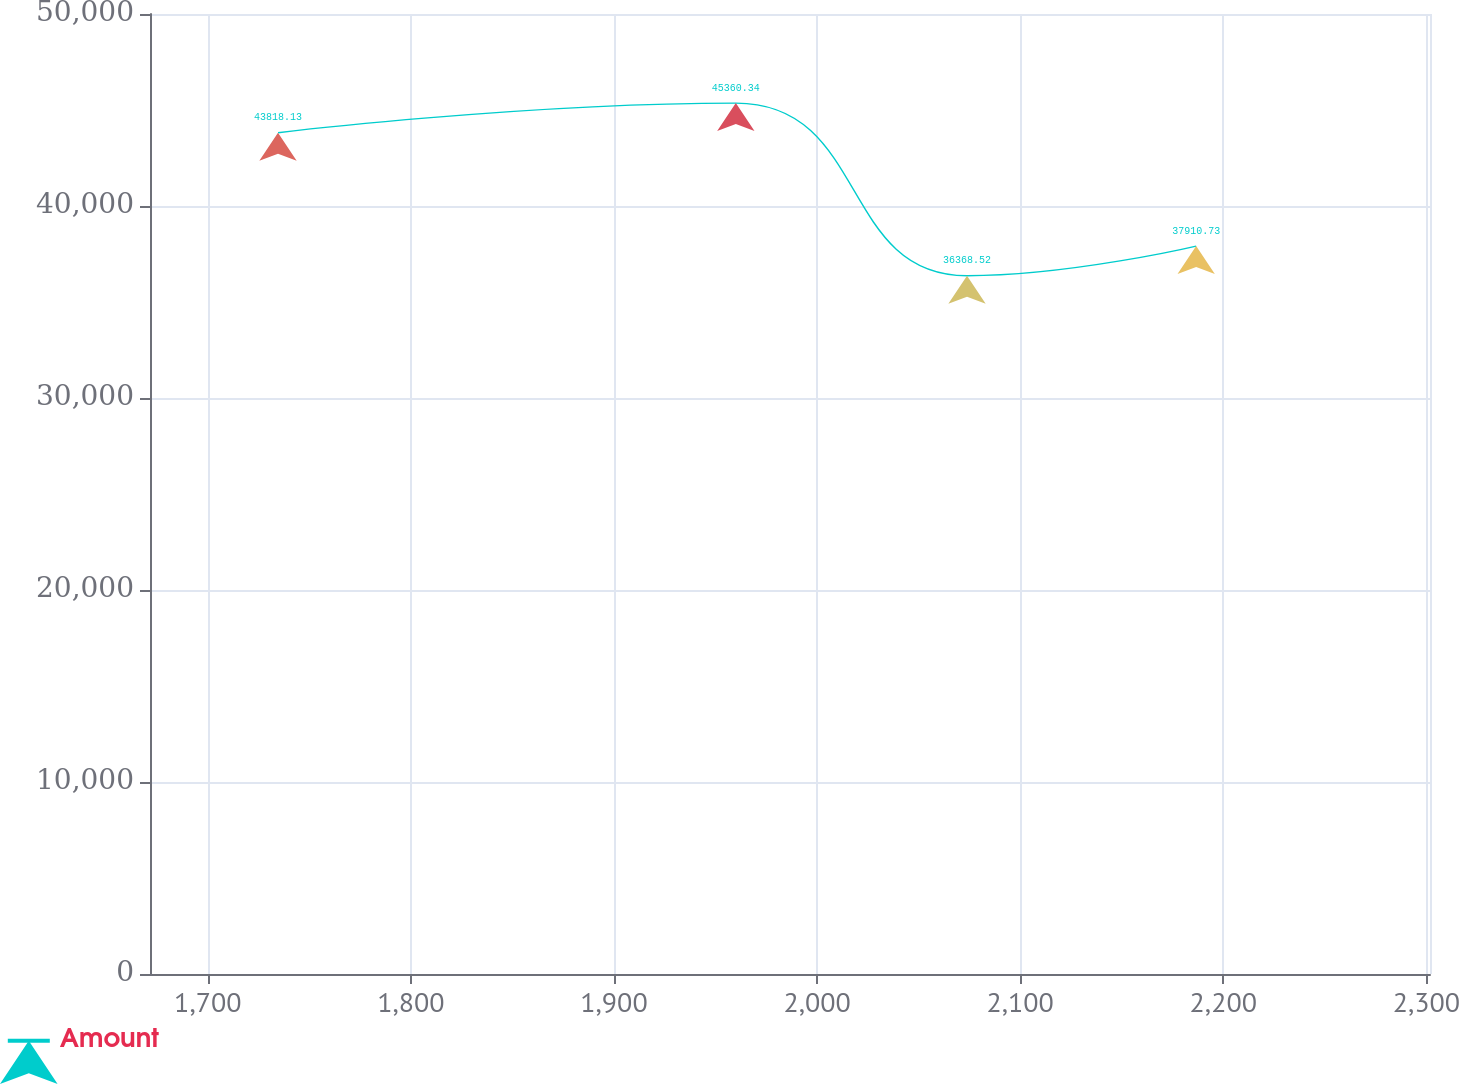Convert chart to OTSL. <chart><loc_0><loc_0><loc_500><loc_500><line_chart><ecel><fcel>Amount<nl><fcel>1734.57<fcel>43818.1<nl><fcel>1960<fcel>45360.3<nl><fcel>2073.84<fcel>36368.5<nl><fcel>2186.67<fcel>37910.7<nl><fcel>2364.83<fcel>29624<nl></chart> 